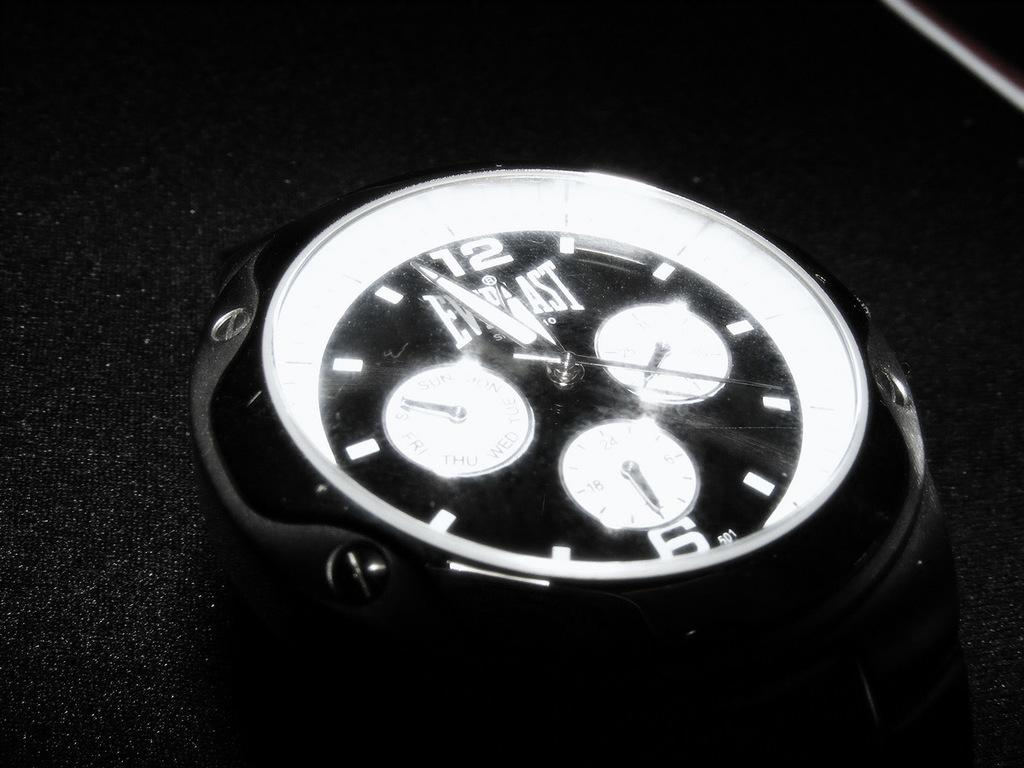<image>
Share a concise interpretation of the image provided. A clock has the word "EVERLAST" on the face. 